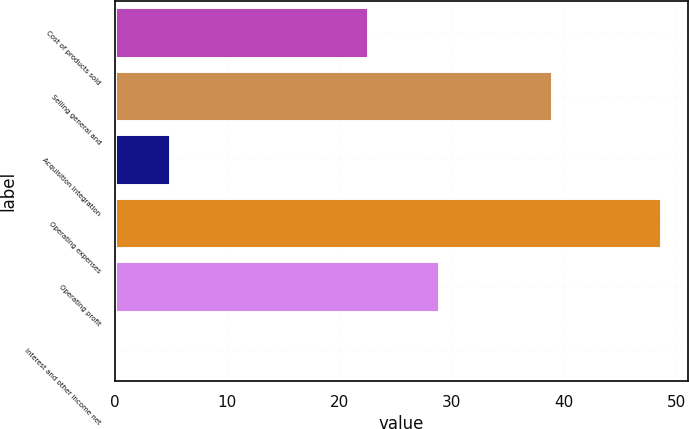Convert chart. <chart><loc_0><loc_0><loc_500><loc_500><bar_chart><fcel>Cost of products sold<fcel>Selling general and<fcel>Acquisition integration<fcel>Operating expenses<fcel>Operating profit<fcel>Interest and other income net<nl><fcel>22.5<fcel>38.9<fcel>4.95<fcel>48.6<fcel>28.9<fcel>0.1<nl></chart> 